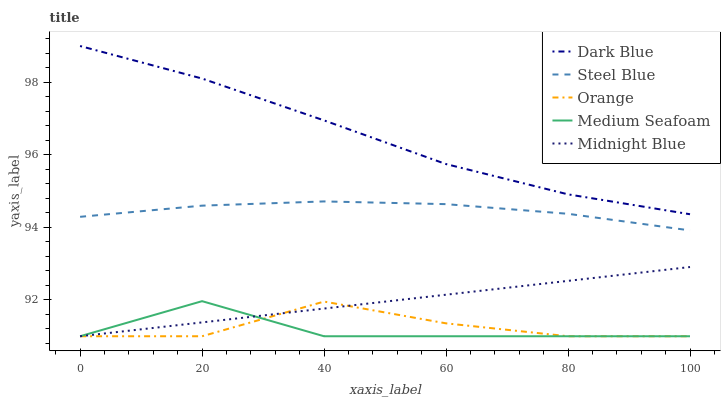Does Medium Seafoam have the minimum area under the curve?
Answer yes or no. Yes. Does Dark Blue have the maximum area under the curve?
Answer yes or no. Yes. Does Midnight Blue have the minimum area under the curve?
Answer yes or no. No. Does Midnight Blue have the maximum area under the curve?
Answer yes or no. No. Is Midnight Blue the smoothest?
Answer yes or no. Yes. Is Orange the roughest?
Answer yes or no. Yes. Is Dark Blue the smoothest?
Answer yes or no. No. Is Dark Blue the roughest?
Answer yes or no. No. Does Orange have the lowest value?
Answer yes or no. Yes. Does Dark Blue have the lowest value?
Answer yes or no. No. Does Dark Blue have the highest value?
Answer yes or no. Yes. Does Midnight Blue have the highest value?
Answer yes or no. No. Is Steel Blue less than Dark Blue?
Answer yes or no. Yes. Is Dark Blue greater than Orange?
Answer yes or no. Yes. Does Midnight Blue intersect Orange?
Answer yes or no. Yes. Is Midnight Blue less than Orange?
Answer yes or no. No. Is Midnight Blue greater than Orange?
Answer yes or no. No. Does Steel Blue intersect Dark Blue?
Answer yes or no. No. 